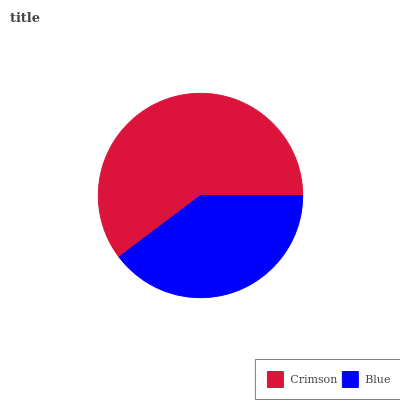Is Blue the minimum?
Answer yes or no. Yes. Is Crimson the maximum?
Answer yes or no. Yes. Is Blue the maximum?
Answer yes or no. No. Is Crimson greater than Blue?
Answer yes or no. Yes. Is Blue less than Crimson?
Answer yes or no. Yes. Is Blue greater than Crimson?
Answer yes or no. No. Is Crimson less than Blue?
Answer yes or no. No. Is Crimson the high median?
Answer yes or no. Yes. Is Blue the low median?
Answer yes or no. Yes. Is Blue the high median?
Answer yes or no. No. Is Crimson the low median?
Answer yes or no. No. 